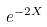Convert formula to latex. <formula><loc_0><loc_0><loc_500><loc_500>e ^ { - 2 { X } }</formula> 